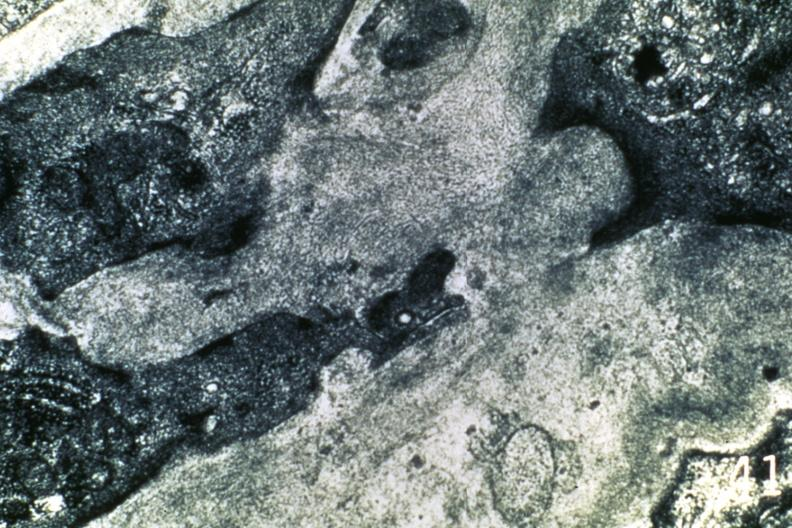where is this area in the body?
Answer the question using a single word or phrase. Heart 